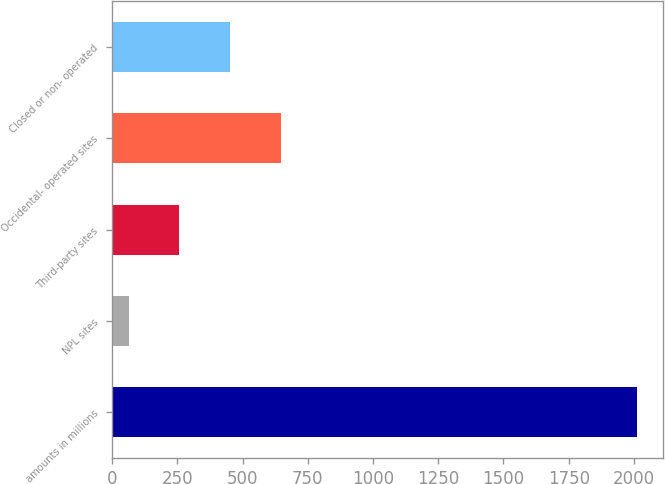<chart> <loc_0><loc_0><loc_500><loc_500><bar_chart><fcel>amounts in millions<fcel>NPL sites<fcel>Third-party sites<fcel>Occidental- operated sites<fcel>Closed or non- operated<nl><fcel>2011<fcel>63<fcel>257.8<fcel>647.4<fcel>452.6<nl></chart> 